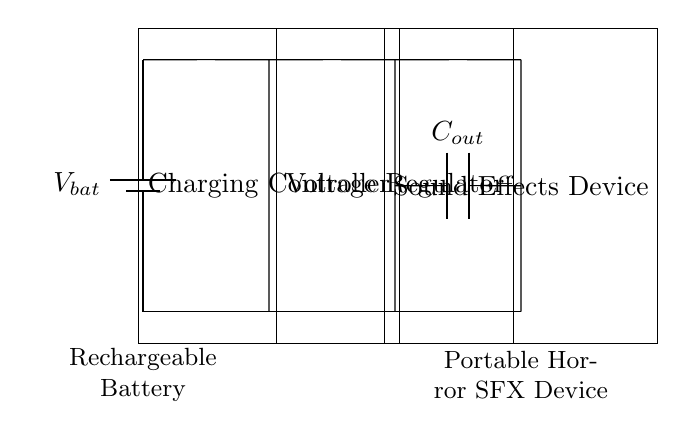What component regulates the output voltage? The voltage regulator, positioned between the charging controller and the output capacitor, is responsible for maintaining a consistent output voltage to the sound effects device.
Answer: Voltage Regulator What is the load in this circuit? The sound effects device serves as the load that draws power from the battery and is powered by the regulated output voltage provided by the circuit.
Answer: Sound Effects Device What does C_{out} stand for? C_{out} represents the output capacitor, which smooths the voltage to provide a stable power supply to the load by reducing voltage fluctuations.
Answer: Output Capacitor How many main components are shown in the circuit? The circuit includes four main components: a battery, a charging controller, a voltage regulator, and an output capacitor connected to the sound effects device.
Answer: Four What is the function of the charging controller? The charging controller manages the charging process of the rechargeable battery, ensuring it operates safely and efficiently while preventing overcharging.
Answer: Charging Controller What is the position of the battery in the circuit? The battery is located at the leftmost part of the circuit diagram, providing the power source for the entire charging circuit.
Answer: Leftmost 